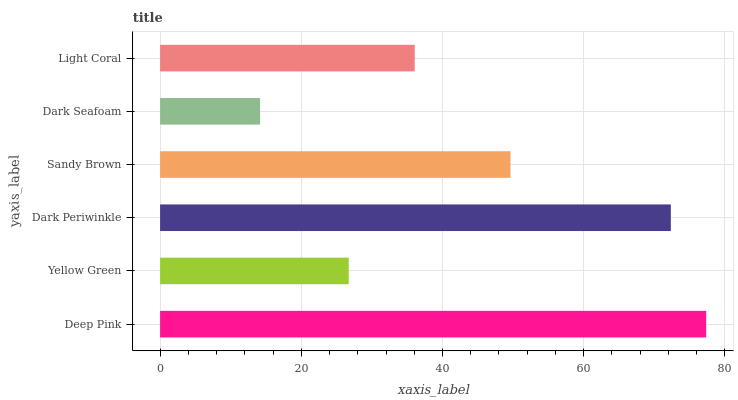Is Dark Seafoam the minimum?
Answer yes or no. Yes. Is Deep Pink the maximum?
Answer yes or no. Yes. Is Yellow Green the minimum?
Answer yes or no. No. Is Yellow Green the maximum?
Answer yes or no. No. Is Deep Pink greater than Yellow Green?
Answer yes or no. Yes. Is Yellow Green less than Deep Pink?
Answer yes or no. Yes. Is Yellow Green greater than Deep Pink?
Answer yes or no. No. Is Deep Pink less than Yellow Green?
Answer yes or no. No. Is Sandy Brown the high median?
Answer yes or no. Yes. Is Light Coral the low median?
Answer yes or no. Yes. Is Yellow Green the high median?
Answer yes or no. No. Is Sandy Brown the low median?
Answer yes or no. No. 